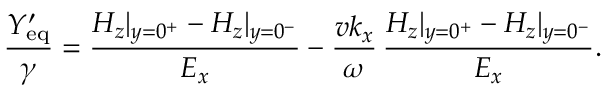<formula> <loc_0><loc_0><loc_500><loc_500>\frac { Y _ { e q } ^ { \prime } } { \gamma } = \frac { H _ { z } | _ { y = 0 ^ { + } } - H _ { z } | _ { y = 0 ^ { - } } } { E _ { x } } - \frac { v k _ { x } } { \omega } \, \frac { H _ { z } | _ { y = 0 ^ { + } } - H _ { z } | _ { y = 0 ^ { - } } } { E _ { x } } .</formula> 